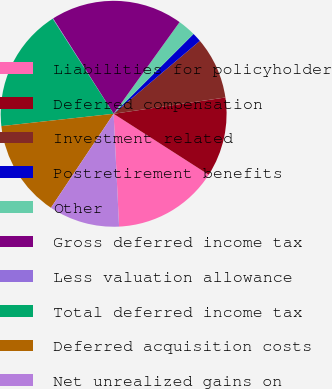<chart> <loc_0><loc_0><loc_500><loc_500><pie_chart><fcel>Liabilities for policyholder<fcel>Deferred compensation<fcel>Investment related<fcel>Postretirement benefits<fcel>Other<fcel>Gross deferred income tax<fcel>Less valuation allowance<fcel>Total deferred income tax<fcel>Deferred acquisition costs<fcel>Net unrealized gains on<nl><fcel>15.16%<fcel>11.38%<fcel>8.87%<fcel>1.32%<fcel>2.58%<fcel>18.93%<fcel>0.07%<fcel>17.67%<fcel>13.9%<fcel>10.13%<nl></chart> 